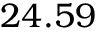<formula> <loc_0><loc_0><loc_500><loc_500>2 4 . 5 9</formula> 